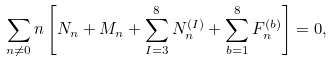<formula> <loc_0><loc_0><loc_500><loc_500>\sum _ { n \neq 0 } n \left [ N _ { n } + M _ { n } + \sum _ { I = 3 } ^ { 8 } N ^ { ( I ) } _ { n } + \sum _ { b = 1 } ^ { 8 } F ^ { ( b ) } _ { n } \right ] = 0 ,</formula> 